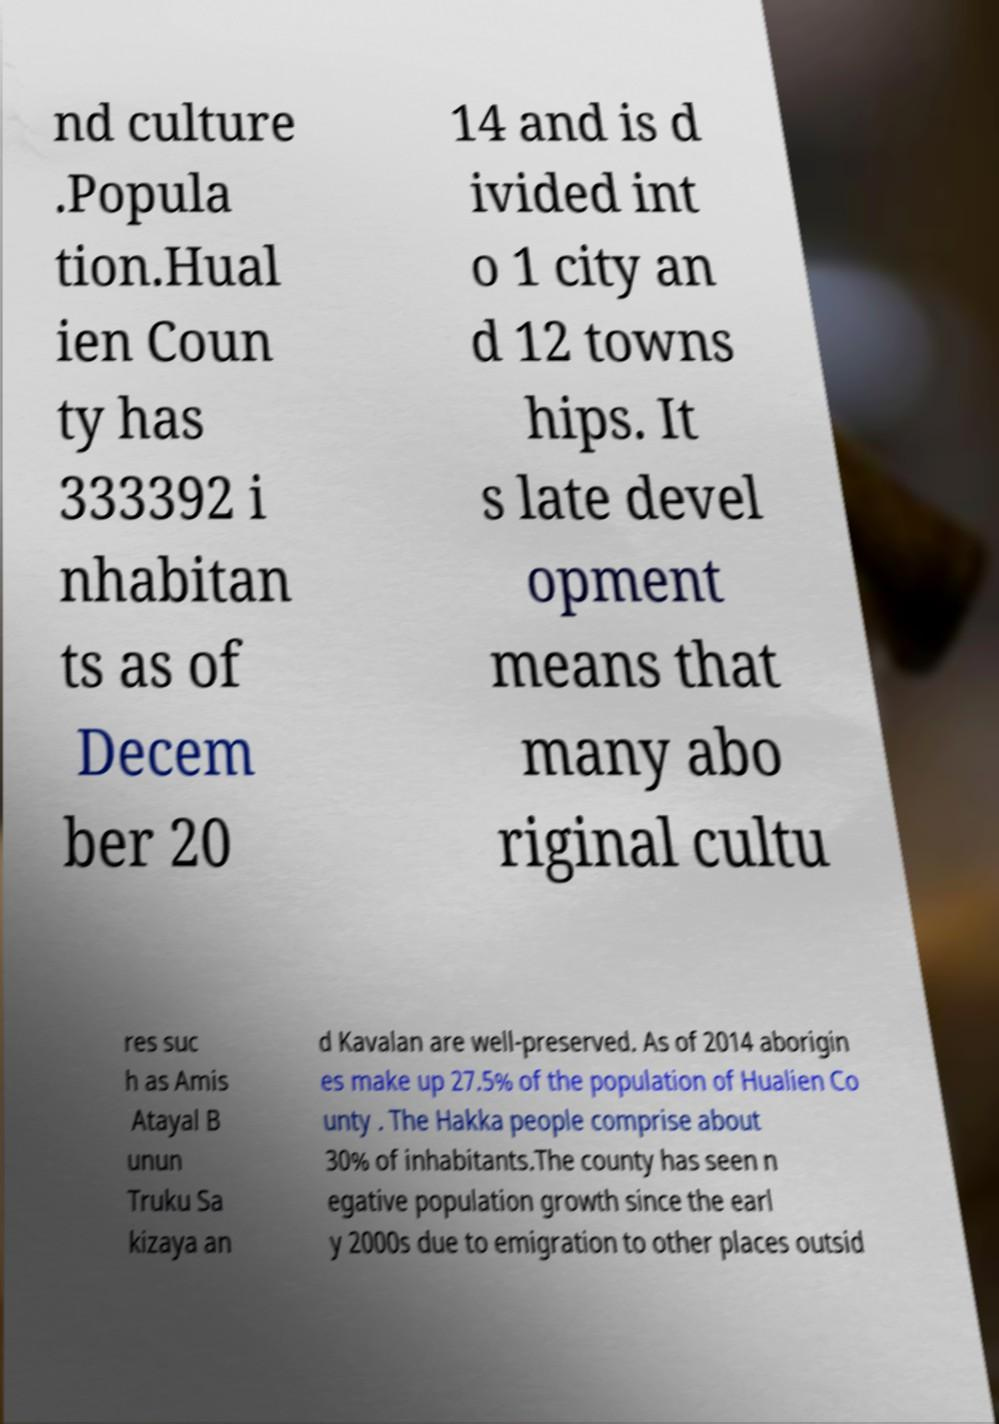Please read and relay the text visible in this image. What does it say? nd culture .Popula tion.Hual ien Coun ty has 333392 i nhabitan ts as of Decem ber 20 14 and is d ivided int o 1 city an d 12 towns hips. It s late devel opment means that many abo riginal cultu res suc h as Amis Atayal B unun Truku Sa kizaya an d Kavalan are well-preserved. As of 2014 aborigin es make up 27.5% of the population of Hualien Co unty . The Hakka people comprise about 30% of inhabitants.The county has seen n egative population growth since the earl y 2000s due to emigration to other places outsid 